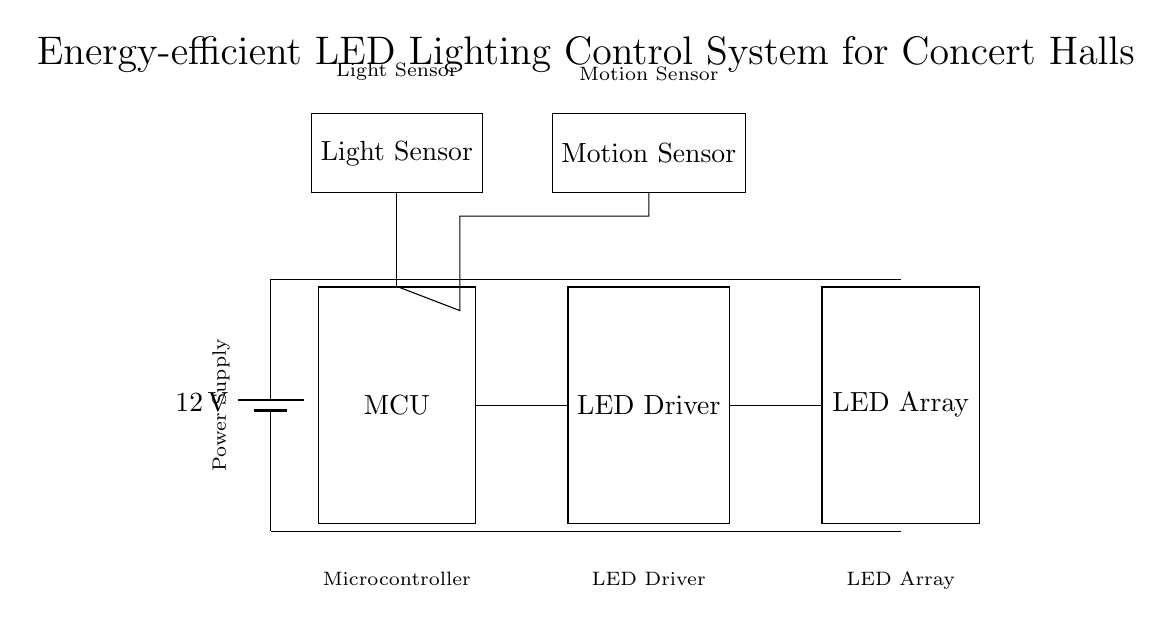What is the voltage of the power supply? The voltage of the power supply is indicated next to the battery symbol, showing a potential difference of twelve volts.
Answer: Twelve volts What components are connected to the microcontroller? The microcontroller is connected to the LED driver and the light sensor. The connections extend from the output of the MCU to the input of the LED driver, and to the light sensor from above.
Answer: LED driver and light sensor What is the function of the motion sensor? The motion sensor detects movement in the environment and sends a signal to the microcontroller to adjust the lighting accordingly, enhancing energy efficiency. Since it's connected to the MCU, its role involves influencing the operation of the lighting system.
Answer: Movement detection How many sensors are present in the circuit? The circuit diagram displays two sensors: a light sensor and a motion sensor. This is identified by the two distinct rectangular blocks labeled for each sensor type, both connected to the microcontroller.
Answer: Two sensors What is the purpose of the LED driver? The LED driver regulates the power supplied to the LED array to ensure proper performance and efficiency, transforming the power from the microcontroller into a suitable format for the LEDs.
Answer: Power regulation for LEDs In what arrangement are the LED array and LED driver connected? The LED array is connected directly in series to the LED driver. The line from the LED driver terminates at the LED array, indicating a direct flow of electricity from one to the other.
Answer: Series arrangement 